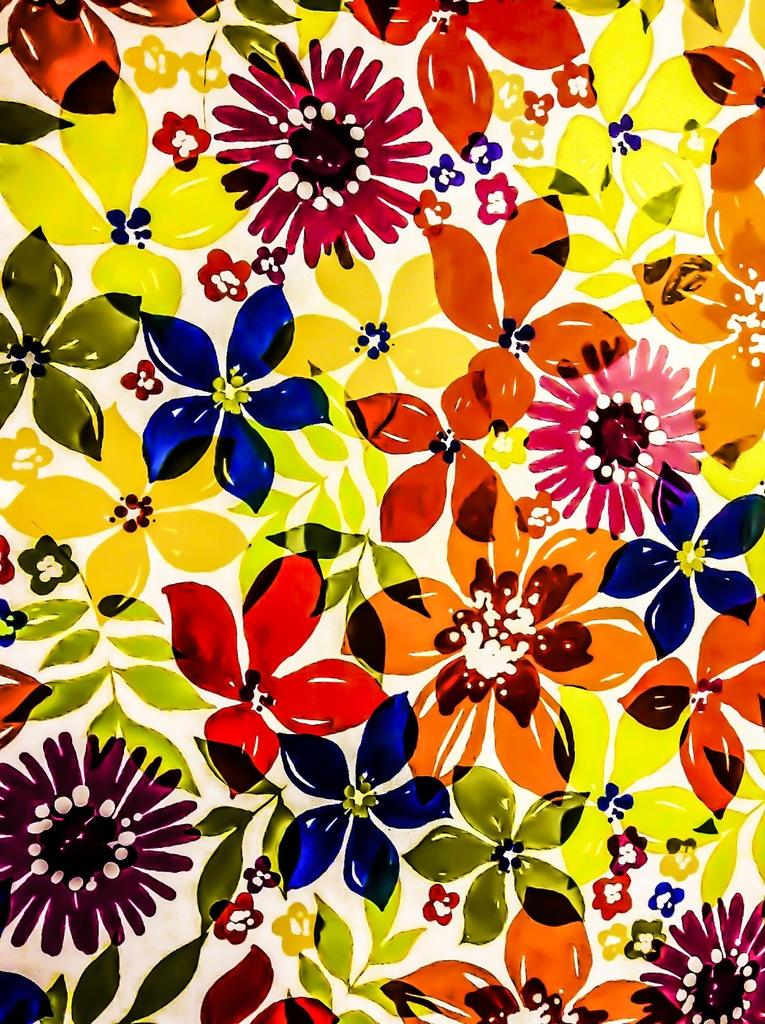What type of artwork is depicted in the image? There are flower paintings in the image. How are the flower paintings described? The flower paintings are described as beautiful. What type of whip is used to create the flower paintings in the image? There is no whip used to create the flower paintings in the image; they are likely created using traditional painting techniques. 